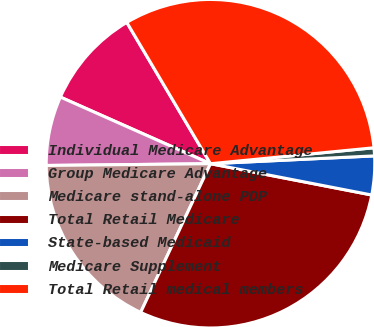<chart> <loc_0><loc_0><loc_500><loc_500><pie_chart><fcel>Individual Medicare Advantage<fcel>Group Medicare Advantage<fcel>Medicare stand-alone PDP<fcel>Total Retail Medicare<fcel>State-based Medicaid<fcel>Medicare Supplement<fcel>Total Retail medical members<nl><fcel>9.84%<fcel>6.82%<fcel>17.84%<fcel>28.94%<fcel>3.81%<fcel>0.79%<fcel>31.96%<nl></chart> 